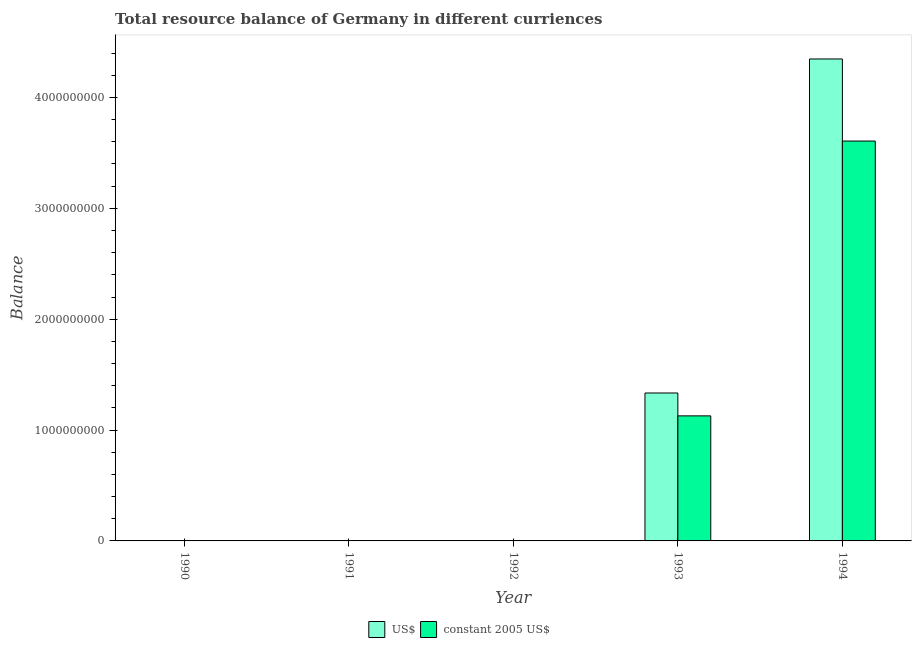How many different coloured bars are there?
Your answer should be very brief. 2. Are the number of bars on each tick of the X-axis equal?
Ensure brevity in your answer.  No. What is the resource balance in constant us$ in 1993?
Provide a short and direct response. 1.13e+09. Across all years, what is the maximum resource balance in constant us$?
Offer a terse response. 3.61e+09. Across all years, what is the minimum resource balance in constant us$?
Keep it short and to the point. 0. What is the total resource balance in constant us$ in the graph?
Ensure brevity in your answer.  4.74e+09. What is the difference between the resource balance in constant us$ in 1994 and the resource balance in us$ in 1991?
Provide a succinct answer. 3.61e+09. What is the average resource balance in us$ per year?
Keep it short and to the point. 1.14e+09. In the year 1993, what is the difference between the resource balance in us$ and resource balance in constant us$?
Provide a succinct answer. 0. Is the resource balance in constant us$ in 1993 less than that in 1994?
Offer a terse response. Yes. What is the difference between the highest and the lowest resource balance in constant us$?
Your answer should be compact. 3.61e+09. In how many years, is the resource balance in us$ greater than the average resource balance in us$ taken over all years?
Offer a terse response. 2. What is the difference between two consecutive major ticks on the Y-axis?
Keep it short and to the point. 1.00e+09. Where does the legend appear in the graph?
Your answer should be compact. Bottom center. How many legend labels are there?
Keep it short and to the point. 2. How are the legend labels stacked?
Keep it short and to the point. Horizontal. What is the title of the graph?
Ensure brevity in your answer.  Total resource balance of Germany in different curriences. What is the label or title of the X-axis?
Your answer should be compact. Year. What is the label or title of the Y-axis?
Provide a short and direct response. Balance. What is the Balance of US$ in 1990?
Ensure brevity in your answer.  0. What is the Balance in constant 2005 US$ in 1990?
Offer a terse response. 0. What is the Balance of US$ in 1991?
Keep it short and to the point. 0. What is the Balance in constant 2005 US$ in 1991?
Ensure brevity in your answer.  0. What is the Balance in US$ in 1992?
Ensure brevity in your answer.  0. What is the Balance of US$ in 1993?
Keep it short and to the point. 1.33e+09. What is the Balance of constant 2005 US$ in 1993?
Make the answer very short. 1.13e+09. What is the Balance in US$ in 1994?
Make the answer very short. 4.35e+09. What is the Balance in constant 2005 US$ in 1994?
Ensure brevity in your answer.  3.61e+09. Across all years, what is the maximum Balance of US$?
Keep it short and to the point. 4.35e+09. Across all years, what is the maximum Balance in constant 2005 US$?
Keep it short and to the point. 3.61e+09. Across all years, what is the minimum Balance in constant 2005 US$?
Provide a short and direct response. 0. What is the total Balance of US$ in the graph?
Your answer should be very brief. 5.68e+09. What is the total Balance of constant 2005 US$ in the graph?
Provide a succinct answer. 4.74e+09. What is the difference between the Balance in US$ in 1993 and that in 1994?
Make the answer very short. -3.01e+09. What is the difference between the Balance of constant 2005 US$ in 1993 and that in 1994?
Keep it short and to the point. -2.48e+09. What is the difference between the Balance of US$ in 1993 and the Balance of constant 2005 US$ in 1994?
Your response must be concise. -2.27e+09. What is the average Balance in US$ per year?
Keep it short and to the point. 1.14e+09. What is the average Balance of constant 2005 US$ per year?
Your answer should be very brief. 9.47e+08. In the year 1993, what is the difference between the Balance in US$ and Balance in constant 2005 US$?
Your answer should be very brief. 2.06e+08. In the year 1994, what is the difference between the Balance of US$ and Balance of constant 2005 US$?
Provide a succinct answer. 7.40e+08. What is the ratio of the Balance in US$ in 1993 to that in 1994?
Offer a terse response. 0.31. What is the ratio of the Balance of constant 2005 US$ in 1993 to that in 1994?
Ensure brevity in your answer.  0.31. What is the difference between the highest and the lowest Balance in US$?
Offer a terse response. 4.35e+09. What is the difference between the highest and the lowest Balance of constant 2005 US$?
Make the answer very short. 3.61e+09. 